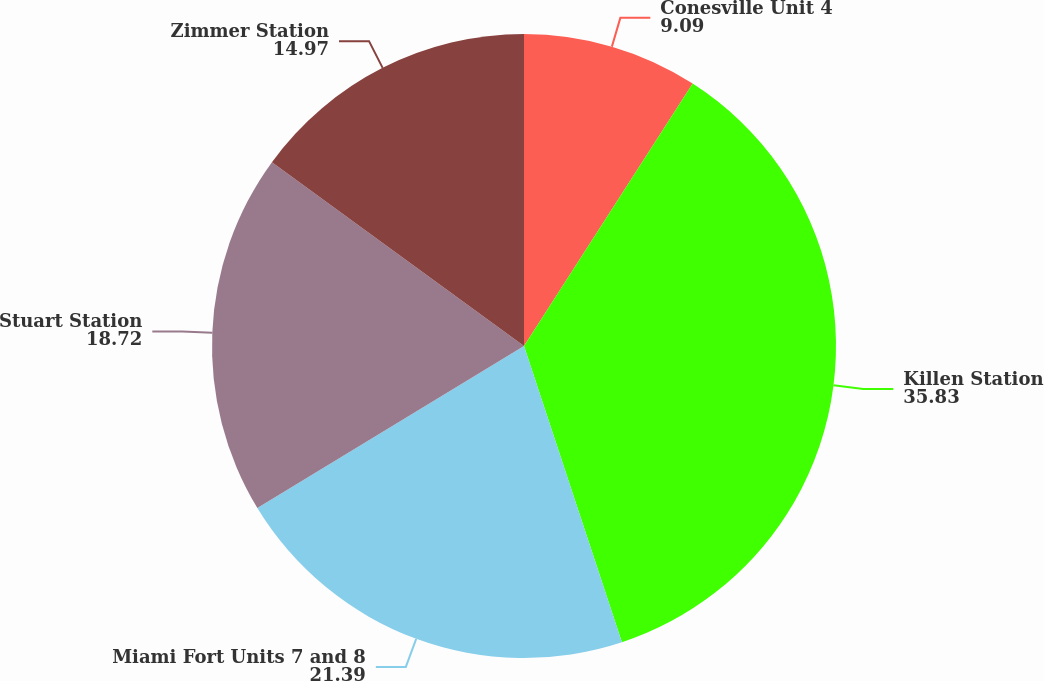Convert chart. <chart><loc_0><loc_0><loc_500><loc_500><pie_chart><fcel>Conesville Unit 4<fcel>Killen Station<fcel>Miami Fort Units 7 and 8<fcel>Stuart Station<fcel>Zimmer Station<nl><fcel>9.09%<fcel>35.83%<fcel>21.39%<fcel>18.72%<fcel>14.97%<nl></chart> 